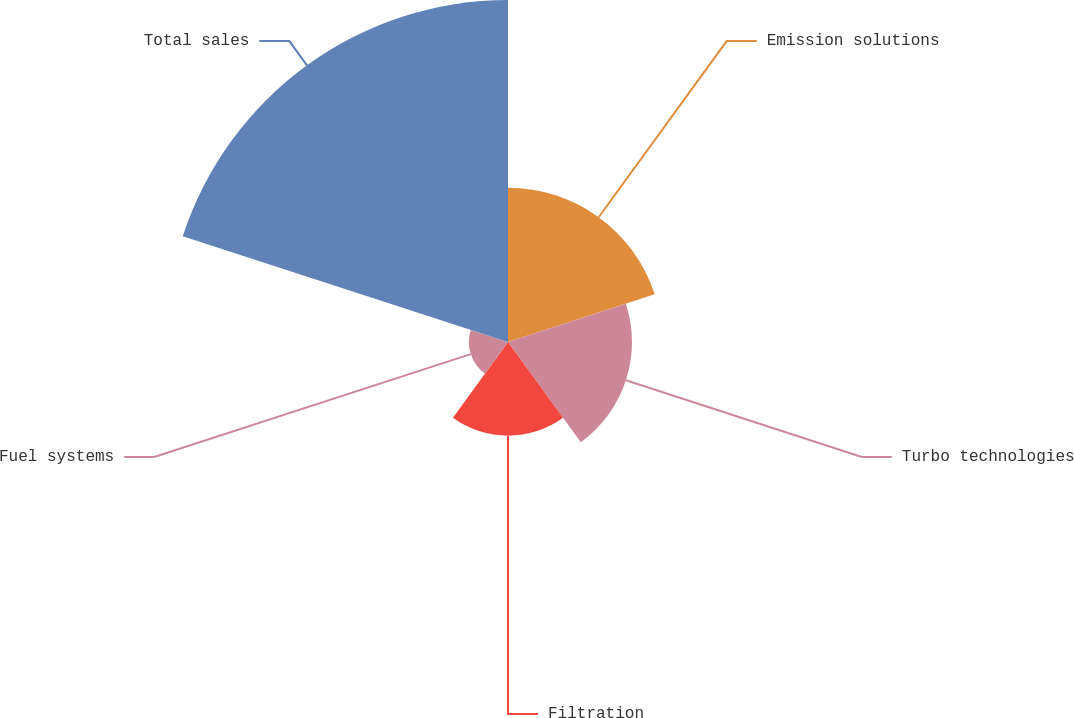Convert chart to OTSL. <chart><loc_0><loc_0><loc_500><loc_500><pie_chart><fcel>Emission solutions<fcel>Turbo technologies<fcel>Filtration<fcel>Fuel systems<fcel>Total sales<nl><fcel>20.48%<fcel>16.46%<fcel>12.44%<fcel>5.2%<fcel>45.41%<nl></chart> 